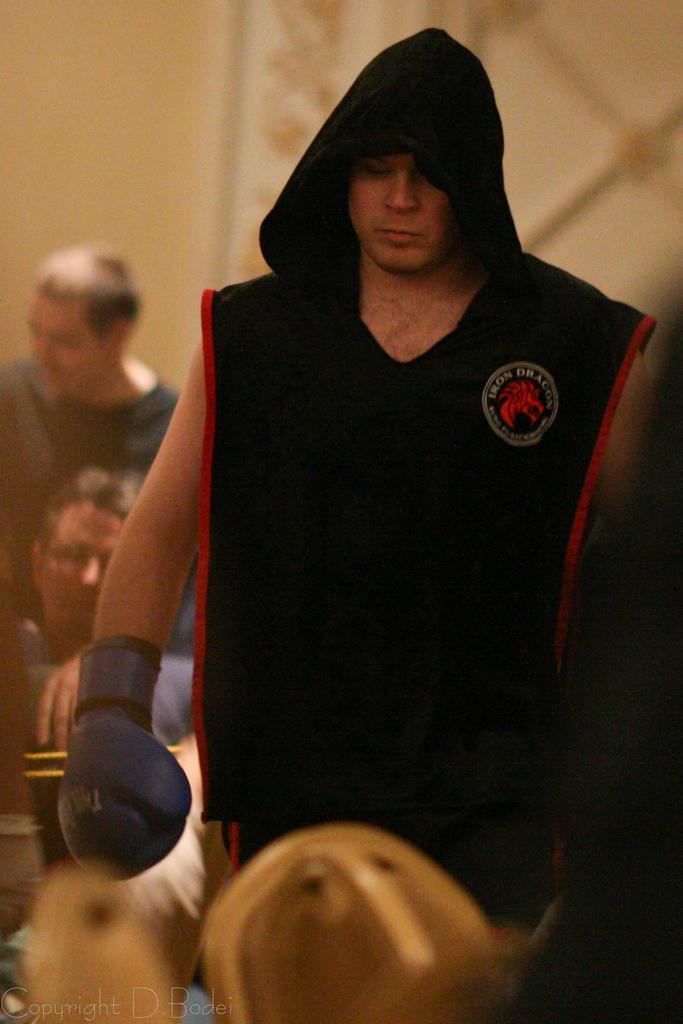Can you describe this image briefly? In this image, I can see the man standing. He wore a boxing glove. I can see a person sitting and another person standing. The background looks blurry. At the bottom of the image, I can see the watermark. 